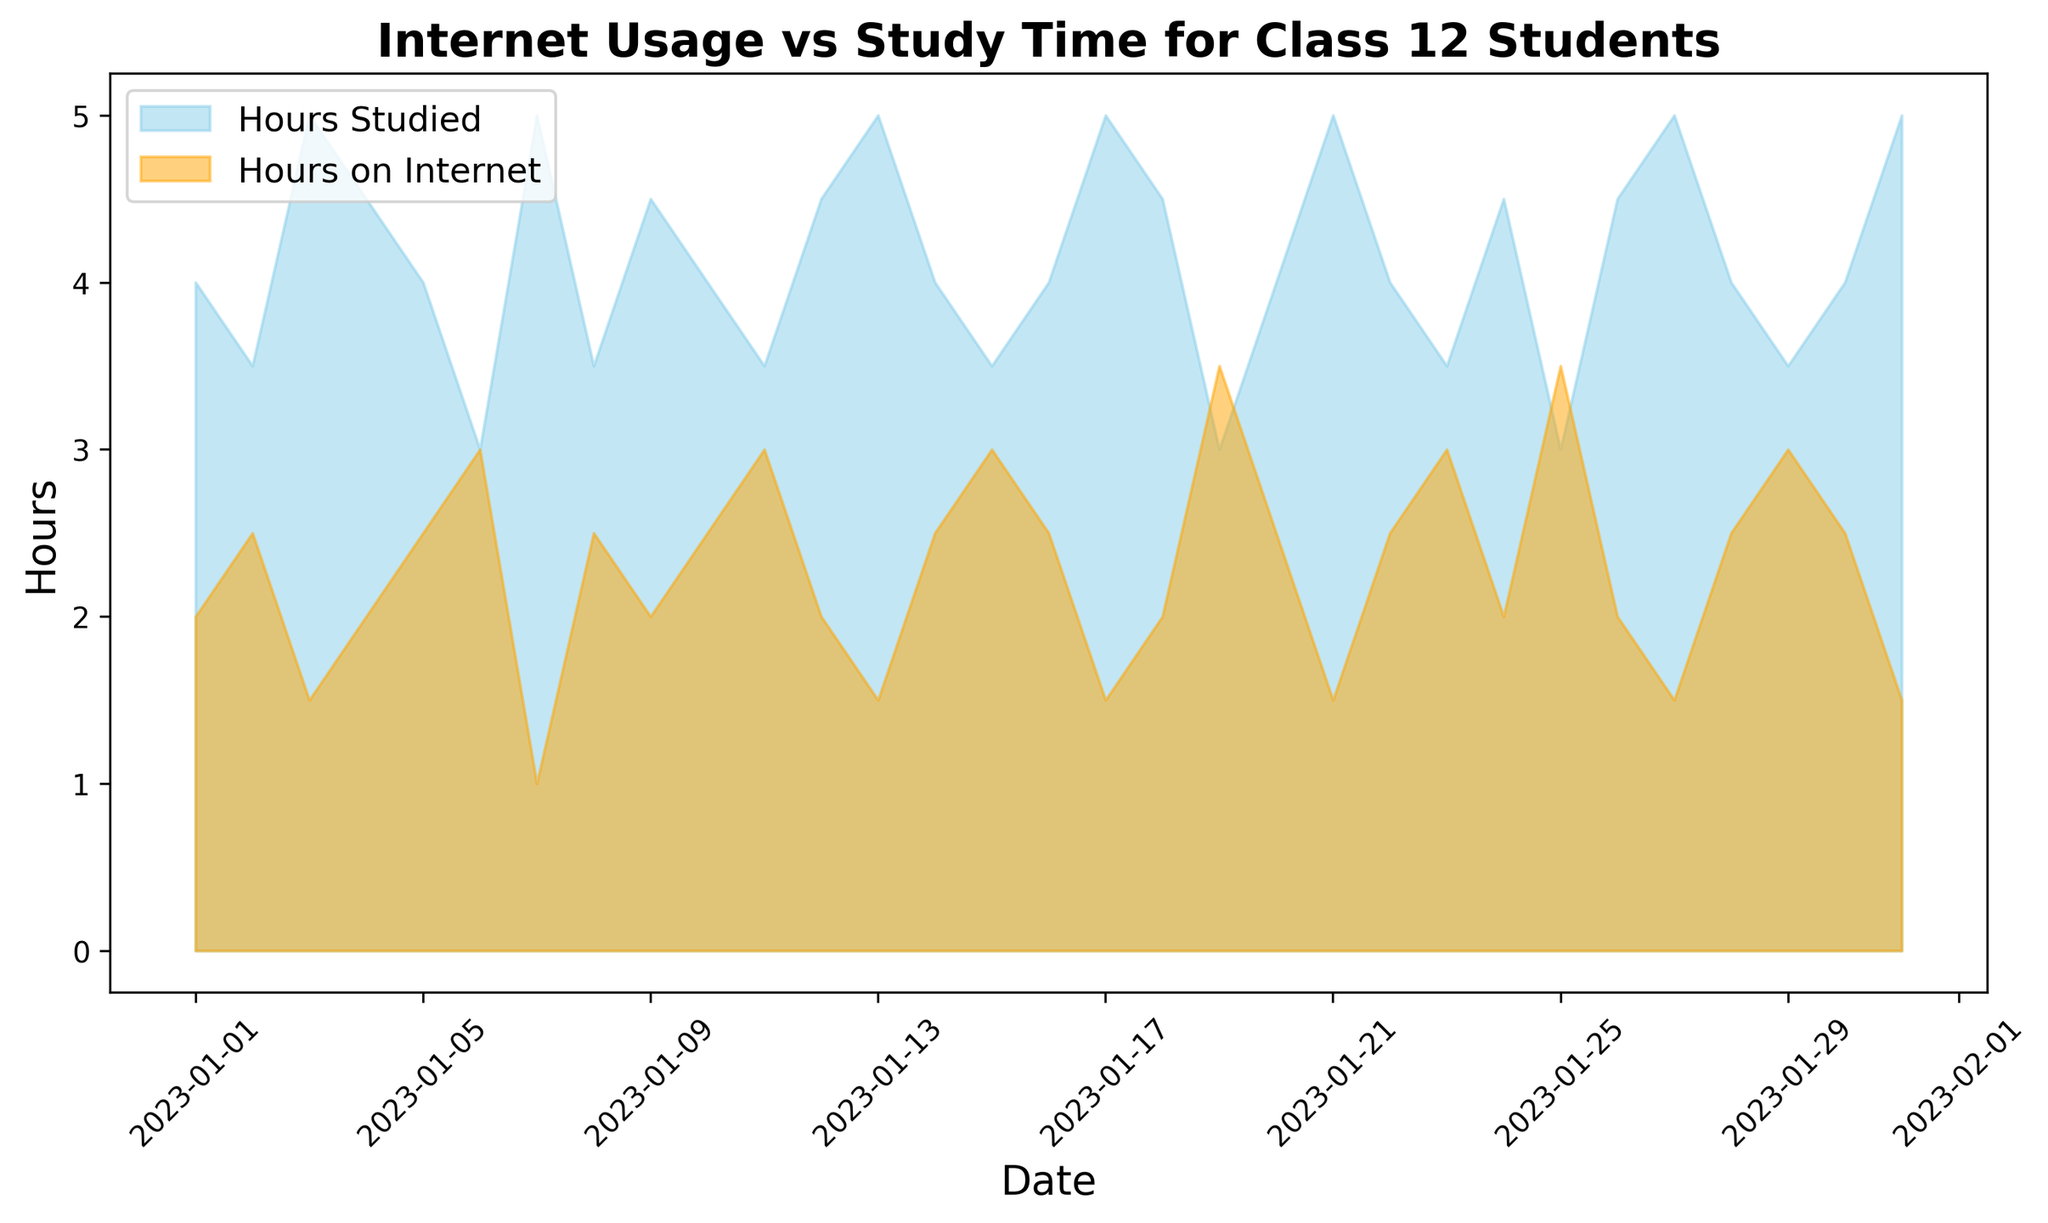What is the general trend for study hours and internet usage over the month? To identify the general trend, observe the pattern of the shaded areas in the figure. Notice that the hours studied generally vary between 3 to 5 hours, while internet usage fluctuates between 1 to 3.5 hours. You can see that on days with lower internet usage (around 1-2 hours), the hours studied are usually higher (around 4-5 hours) and vice versa.
Answer: Inverse relationship On which date did students spend the maximum hours on the internet? To find the date with maximum internet hours, locate the peak in the orange shaded area. The highest peak appears to be on 19th and 25th January where the usage reaches around 3.5 hours.
Answer: January 19 and January 25 How many days did students study for 5 hours? Count the number of peaks in the sky-blue shaded area reaching up to 5 hours. These are on 3rd, 7th, 13th, 17th, 21st, 27th, and 31st January, which totals 7 days.
Answer: 7 days Compare the study hours on January 1 and January 21. Which day had more study hours? To compare, observe the value of the sky-blue shaded area on both dates. On January 1, the study hours are 4, while on January 21, they are 5.
Answer: January 21 What is the sum of study hours on January 4 and January 24? To calculate the sum, add the study hours from the sky-blue shaded areas. On January 4, it's 4.5 hours, and on January 24, it's also 4.5 hours. The sum is 4.5 + 4.5 = 9 hours.
Answer: 9 hours What is the difference between internet usage hours on January 2 and January 8? Find the difference by subtracting the hours of the orange shaded areas. On January 2, it is 2.5 hours, and on January 8, it's also 2.5 hours. The difference is 2.5 - 2.5 = 0 hours.
Answer: 0 hours Which day has the lowest study time in January? Locate the lowest point in the sky-blue shaded area. The lowest point is on January 6 and 19, where the study time is 3 hours.
Answer: January 6 and January 19 What is the average internet usage for the first five days of January? Find the average by summing the internet usage hours for the first five days and dividing by 5. The data is 2, 2.5, 1.5, 2, 2.5, which sums to 10.5. The average is 10.5 / 5 = 2.1 hours.
Answer: 2.1 hours 